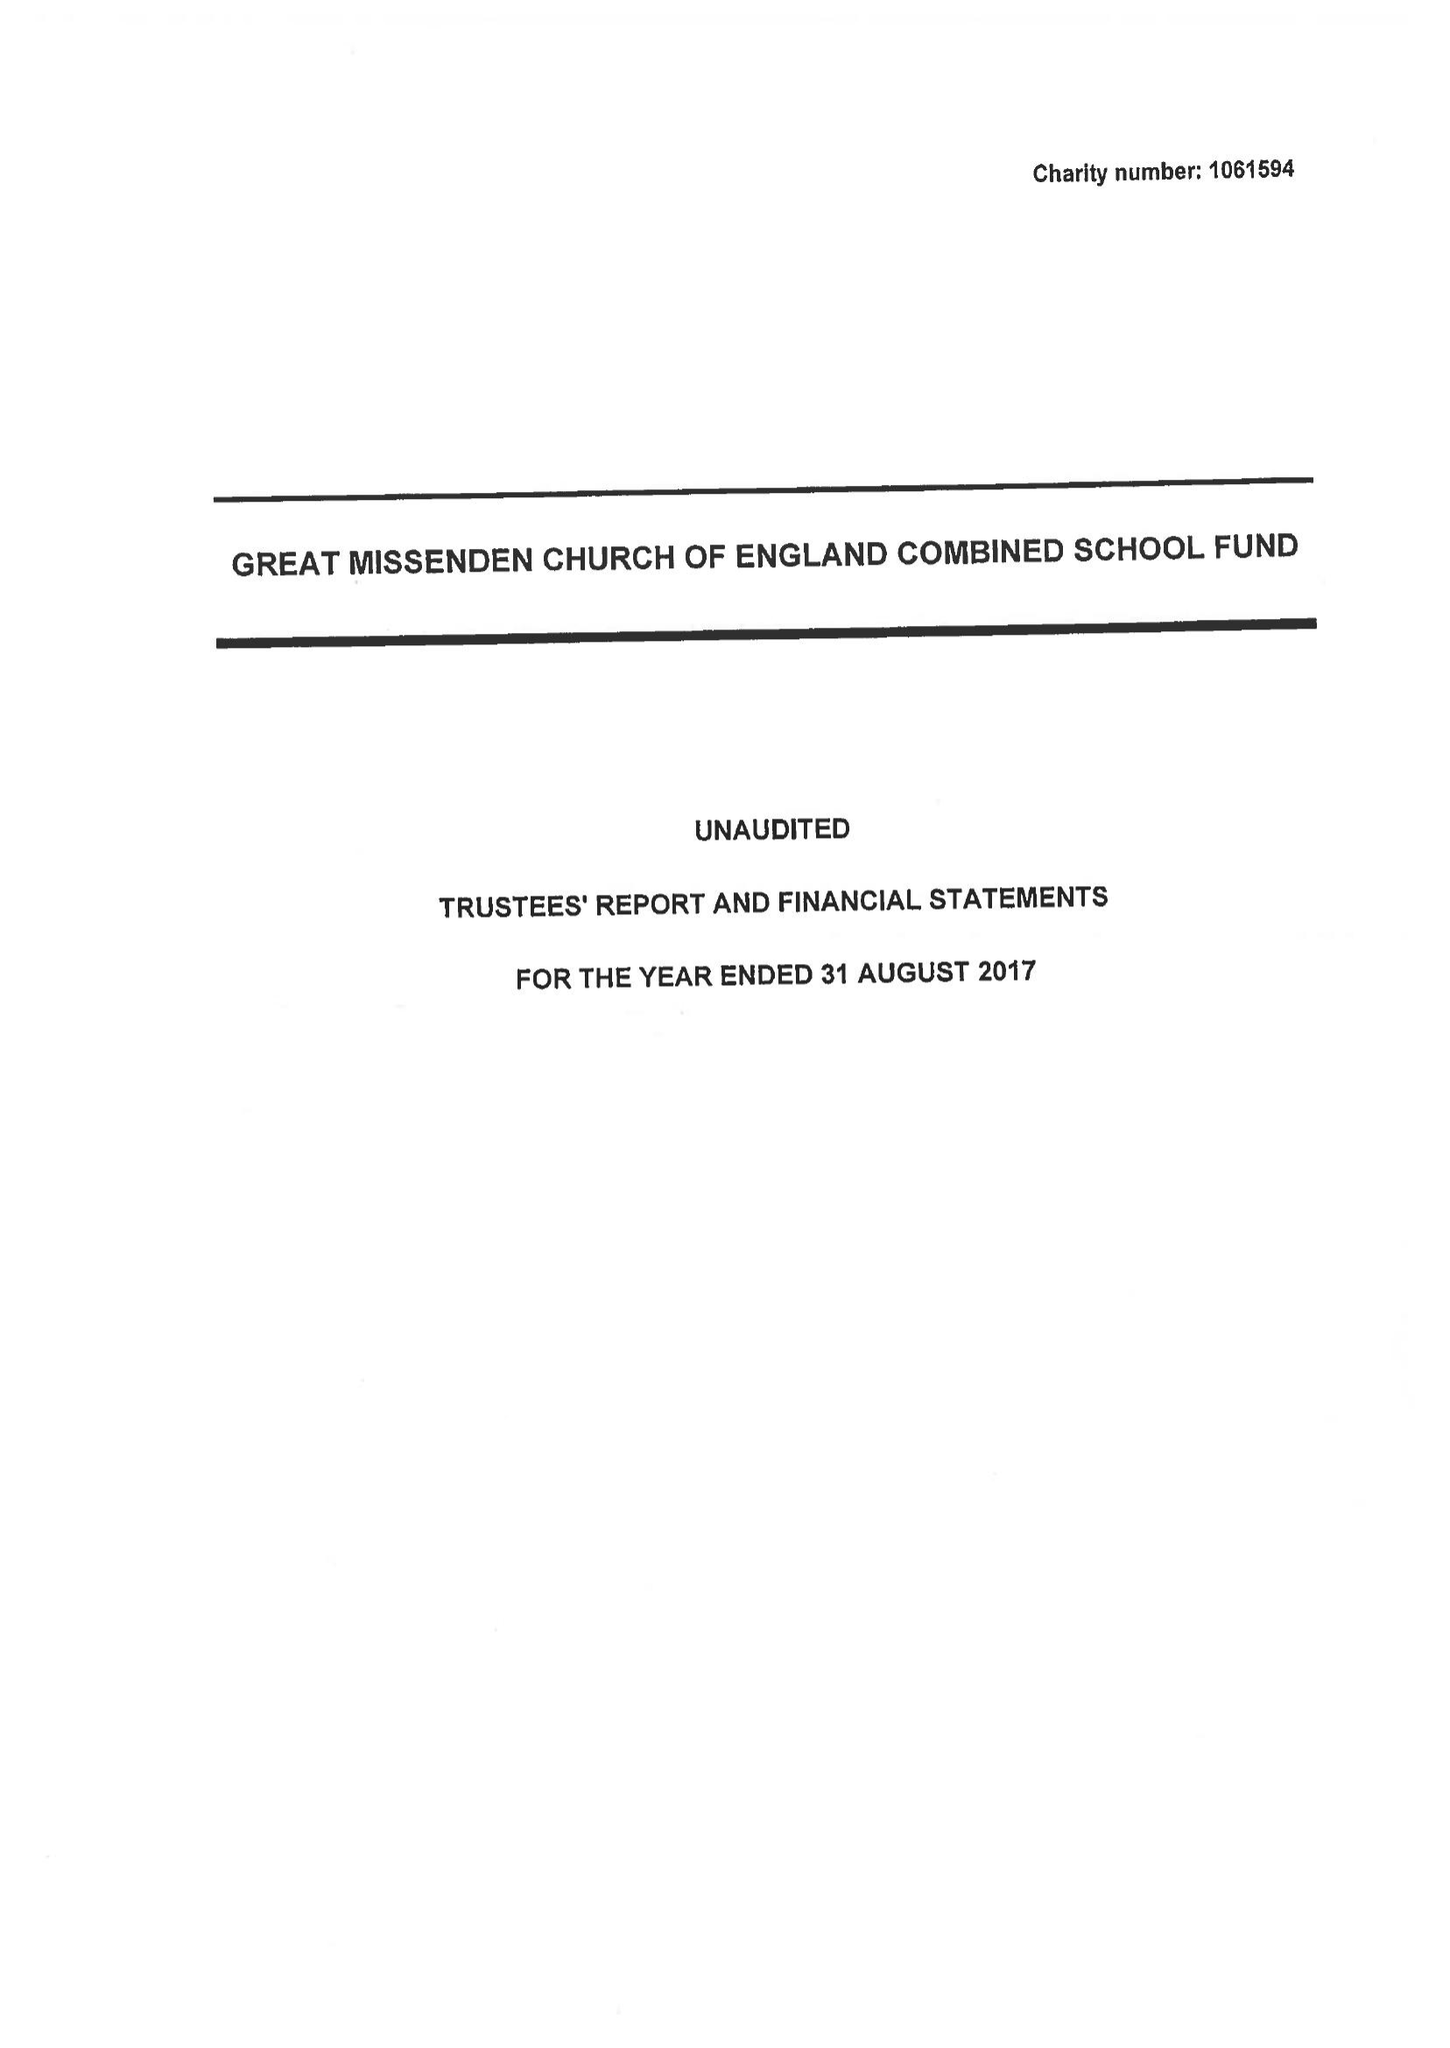What is the value for the spending_annually_in_british_pounds?
Answer the question using a single word or phrase. 108731.00 